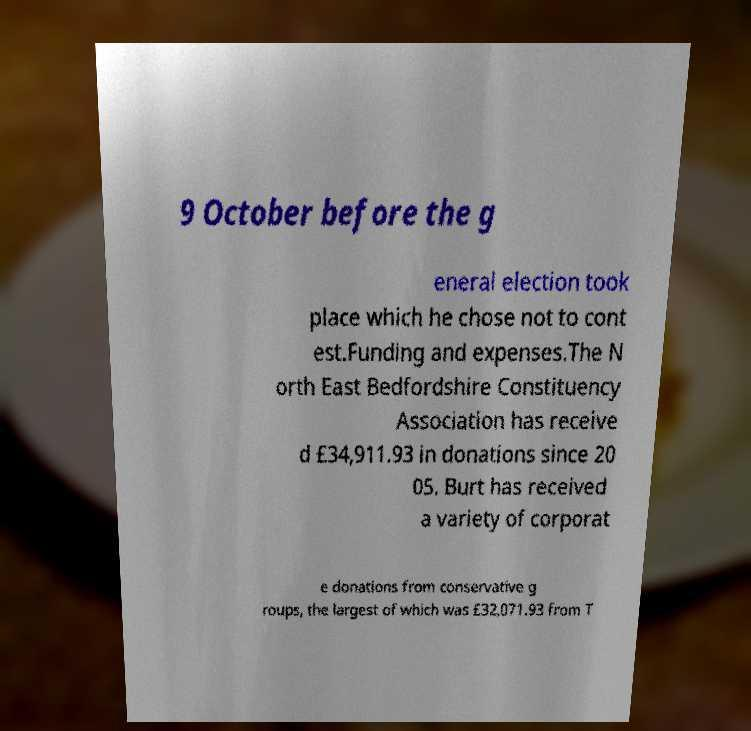There's text embedded in this image that I need extracted. Can you transcribe it verbatim? 9 October before the g eneral election took place which he chose not to cont est.Funding and expenses.The N orth East Bedfordshire Constituency Association has receive d £34,911.93 in donations since 20 05. Burt has received a variety of corporat e donations from conservative g roups, the largest of which was £32,071.93 from T 